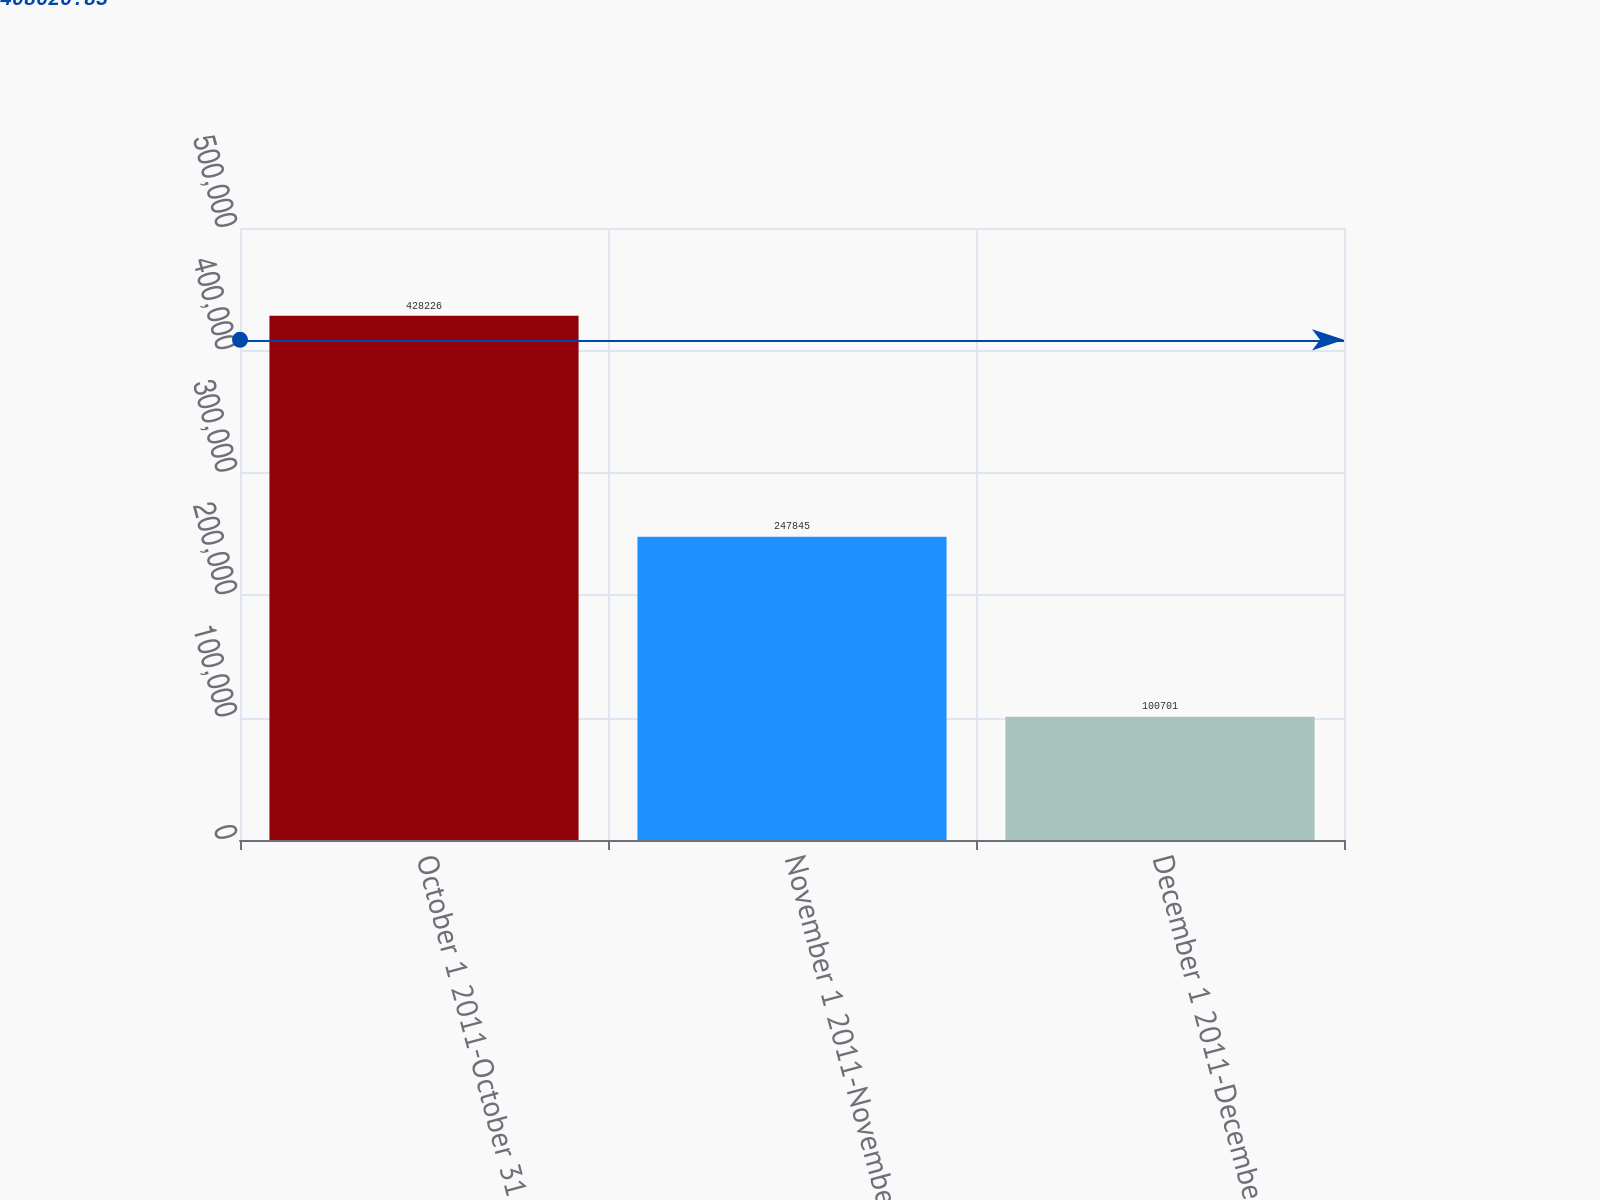Convert chart. <chart><loc_0><loc_0><loc_500><loc_500><bar_chart><fcel>October 1 2011-October 31 2011<fcel>November 1 2011-November 30<fcel>December 1 2011-December 31<nl><fcel>428226<fcel>247845<fcel>100701<nl></chart> 